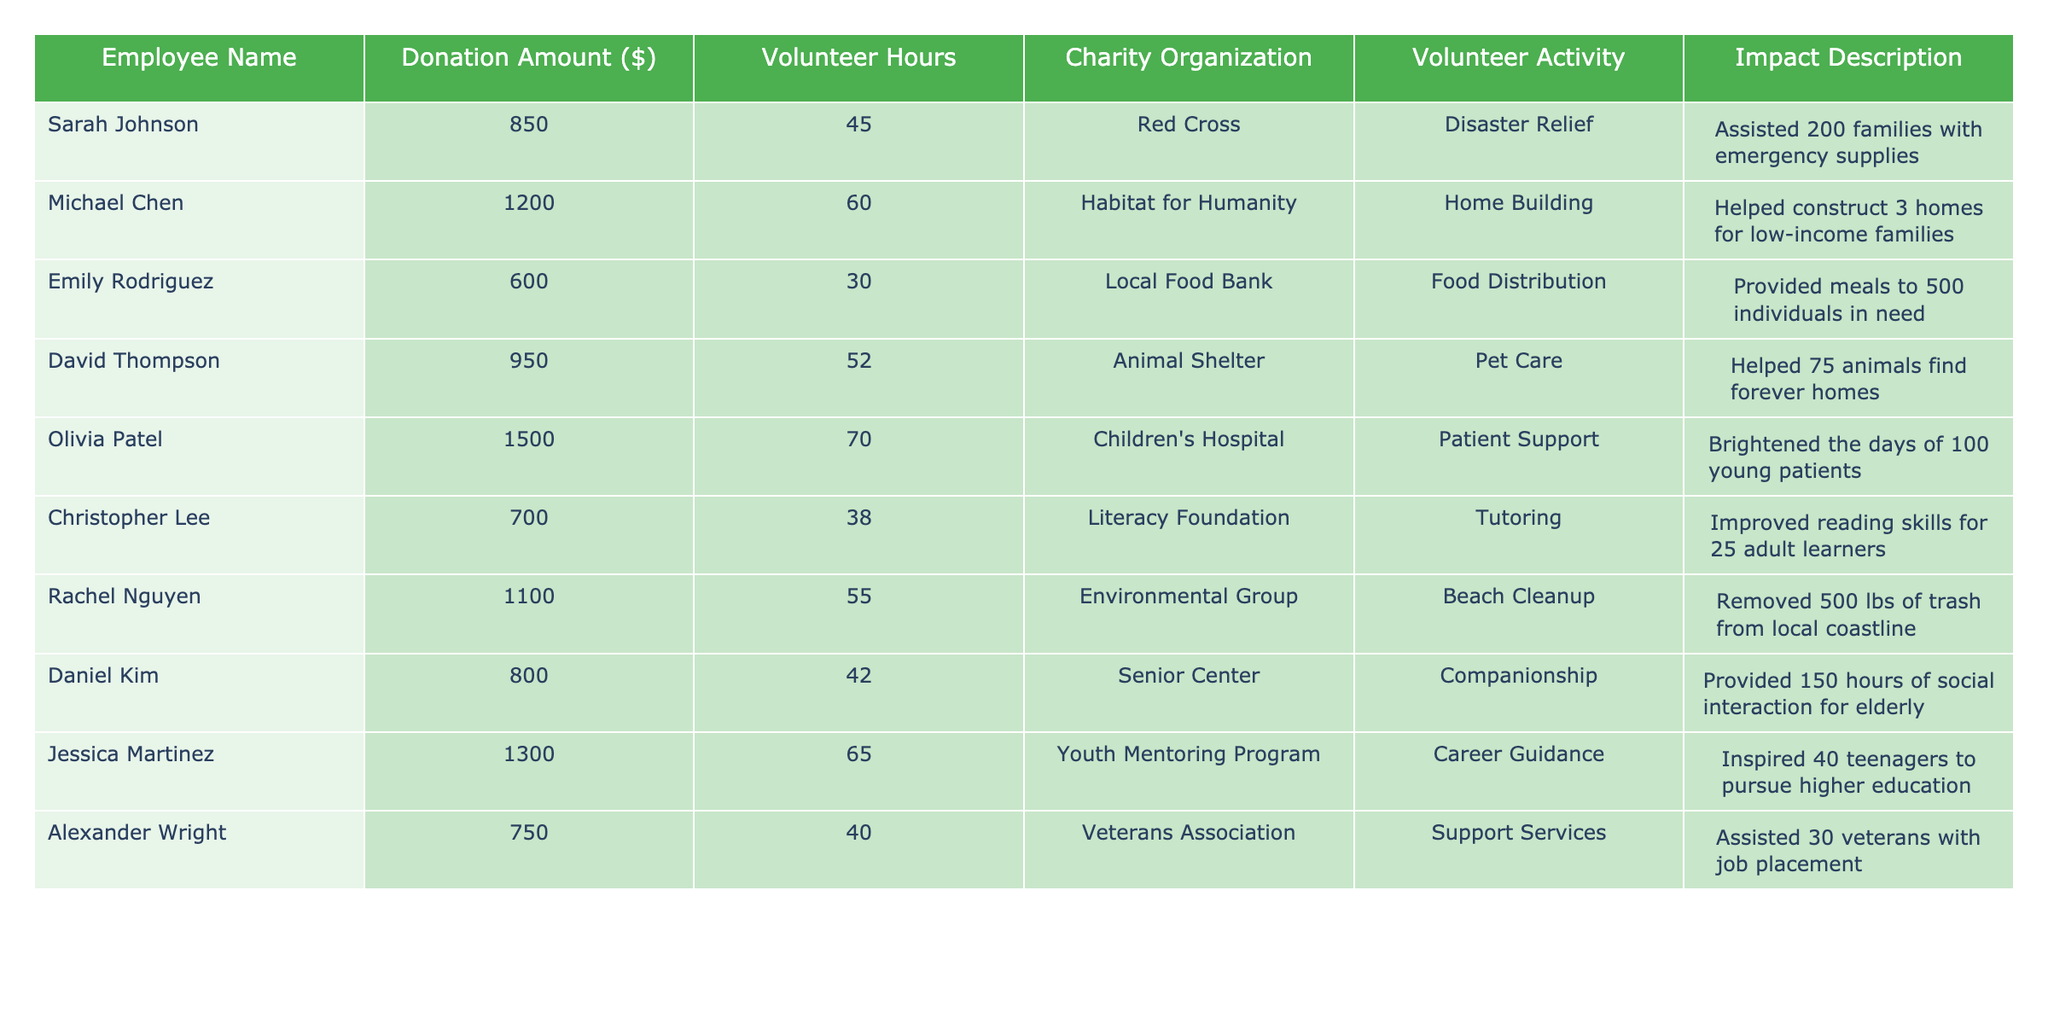What is the highest donation amount from an employee? To find the highest donation amount, I look for the maximum value in the "Donation Amount" column. The maximum value is 1500 from Olivia Patel.
Answer: 1500 Which charity organization received the most donations? I compare the donation amounts associated with each charity organization. The organization with the highest donation amount is Children's Hospital, receiving 1500.
Answer: Children's Hospital How many volunteer hours did Michael Chen contribute? I look at the "Volunteer Hours" column next to Michael Chen's name, which lists 60 hours.
Answer: 60 What is the total amount donated by all employees? I sum all the values in the "Donation Amount" column: 850 + 1200 + 600 + 950 + 1500 + 700 + 1100 + 800 + 1300 + 750 = 8950.
Answer: 8950 What is the average number of volunteer hours across all employees? I sum all the volunteer hours (45 + 60 + 30 + 52 + 70 + 38 + 55 + 42 + 65 + 40 =  452) and divide by the number of employees (10): 452 / 10 = 45.2 hours.
Answer: 45.2 Did any employee volunteer more than 70 hours? I check the "Volunteer Hours" column to see if any values exceed 70. The highest value is 70, contributed by Olivia Patel, so no one volunteered more than 70 hours.
Answer: No Which employee helped the most families or individuals through their volunteer efforts? I review the "Impact Description" to identify the highest number: Sarah Johnson helped 200 families, which is the maximum.
Answer: Sarah Johnson How many total hours were spent volunteering by employees for charity? I add together all the volunteer hours (45 + 60 + 30 + 52 + 70 + 38 + 55 + 42 + 65 + 40 =  452).
Answer: 452 Is there a correlation between donation amount and volunteer hours? By observing the data, I would need to analyze the relationship between donation amounts and volunteer hours, and it appears varied without a clear trend.
Answer: Varied Which organization had the least amount of donations received? I look at the minimum value in the "Donation Amount" column. The least amount is 600, associated with the Local Food Bank.
Answer: Local Food Bank Who contributed to the highest number of volunteer hours? I find the maximum value in the "Volunteer Hours" column, which is 70 hours from Olivia Patel.
Answer: Olivia Patel 